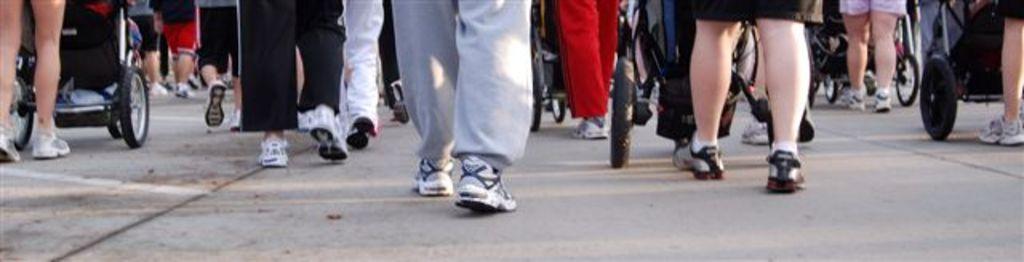Describe this image in one or two sentences. In this picture we can see a group of people walking and vehicles on the road. 